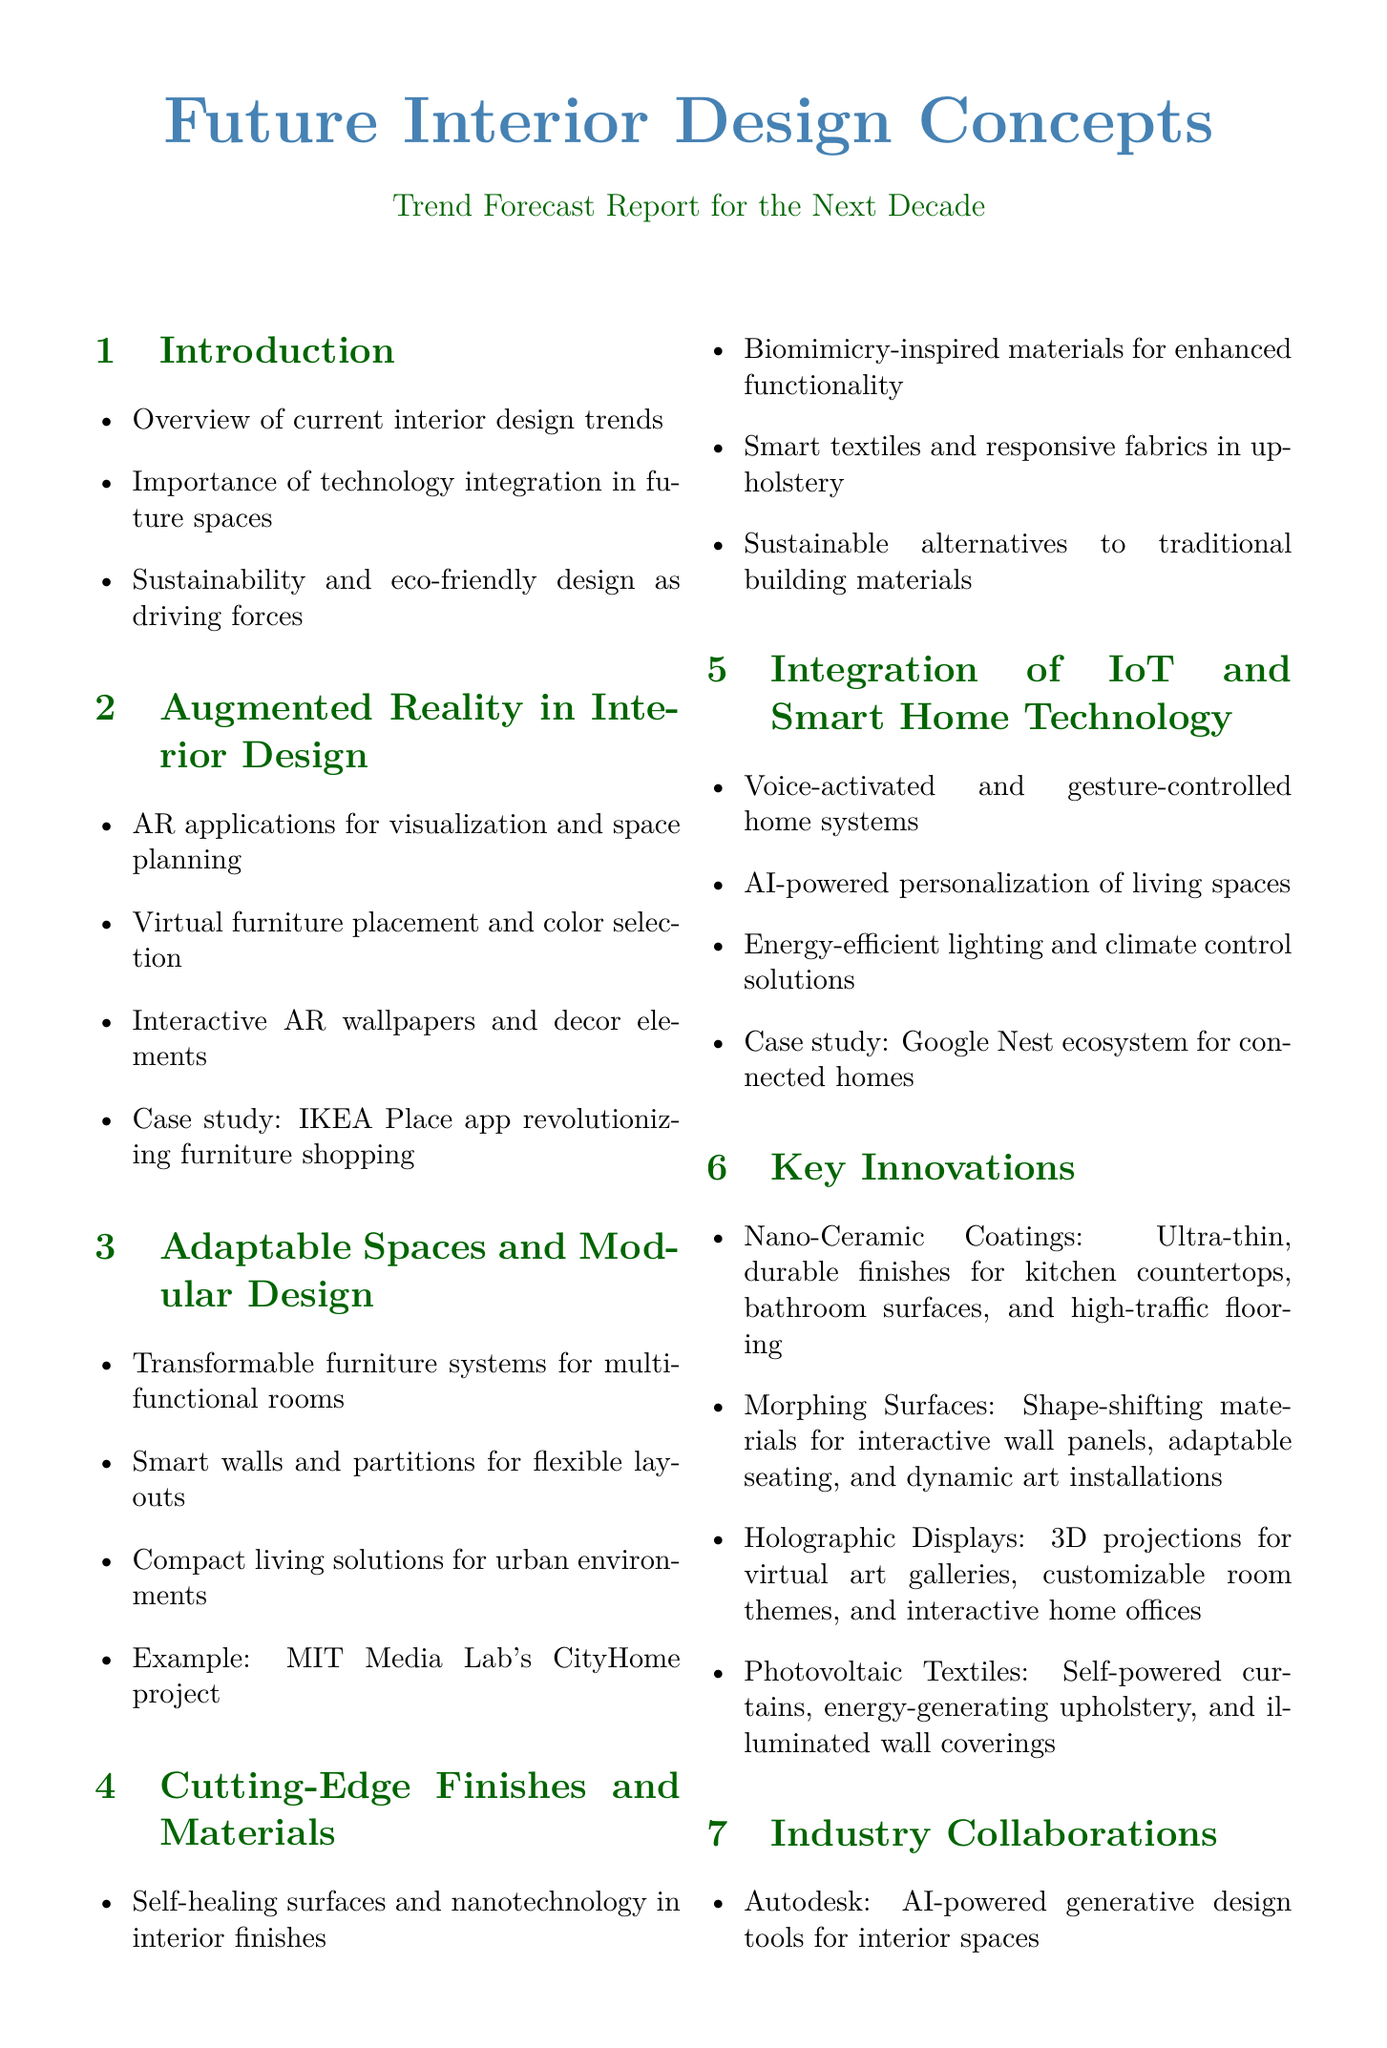What is the first section of the report? The first section introduces the topic and discusses current trends and technology in interior design.
Answer: Introduction to Future Interior Design Concepts Which company is associated with AI-powered generative design tools? The report mentions Autodesk as the company partnering in the project.
Answer: Autodesk What type of materials are suggested for self-healing surfaces? The report describes the use of nanotechnology in creating self-healing surfaces.
Answer: Nanotechnology Name a project that exemplifies adaptable spaces. An example provided in the document is the MIT Media Lab's CityHome project.
Answer: MIT Media Lab's CityHome project What is a significant benefit of biophilic design mentioned in the report? The document highlights living walls and natural light optimization as benefits of biophilic design.
Answer: Living walls How are photovoltaic textiles beneficial? The report explains that these textiles generate electricity from light exposure.
Answer: Generate electricity What does the report suggest as a sustainable alternative for traditional building materials? It mentions bamboo engineered lumber as a rapidly renewable resource.
Answer: Bamboo Engineered Lumber In which area is Steelcase making advancements according to the report? The report states that Steelcase is focusing on adaptive workspaces with embedded sensors.
Answer: Adaptive workspaces What future challenge does the report identify? Balancing technology integration with human-centric design is mentioned as a challenge.
Answer: Balancing technology integration 